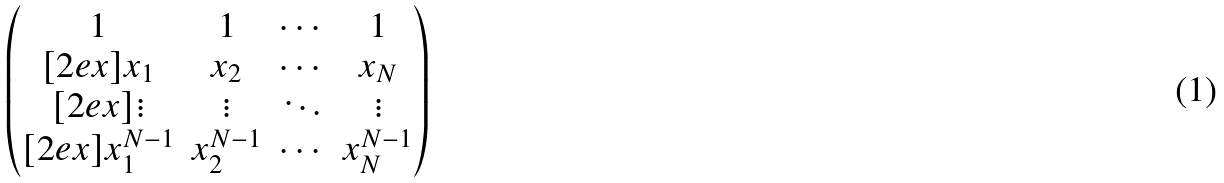Convert formula to latex. <formula><loc_0><loc_0><loc_500><loc_500>\begin{pmatrix} 1 & 1 & \cdots & 1 \\ [ 2 e x ] x _ { 1 } & x _ { 2 } & \cdots & x _ { N } \\ [ 2 e x ] \vdots & \vdots & \ddots & \vdots \\ [ 2 e x ] x _ { 1 } ^ { N - 1 } & x _ { 2 } ^ { N - 1 } & \cdots & x _ { N } ^ { N - 1 } \end{pmatrix}</formula> 